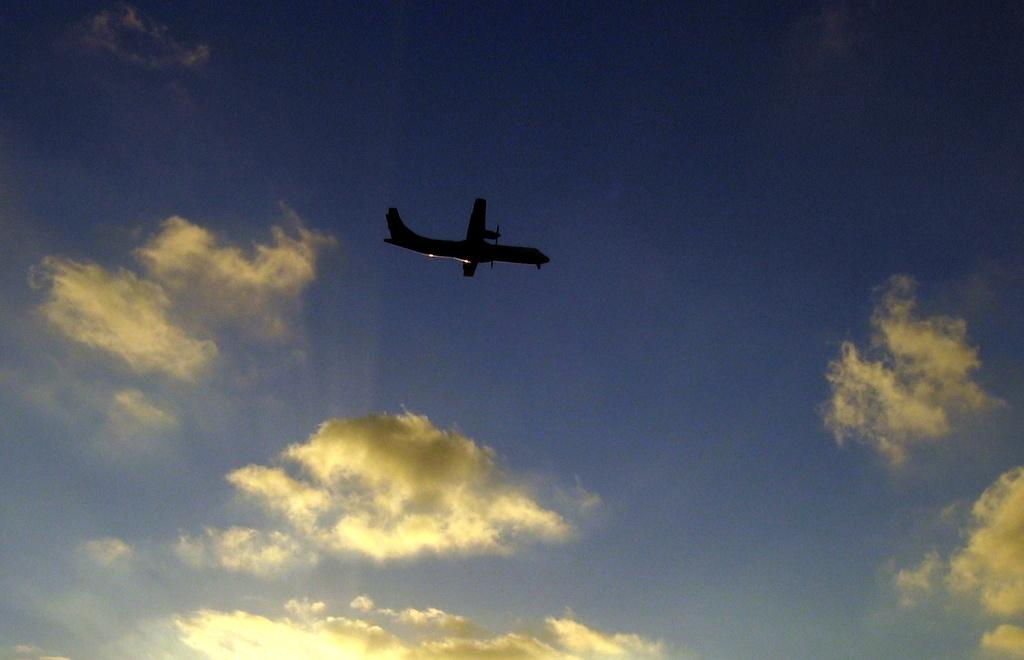What is the main subject of the image? There is a plane in the image. What is the plane doing in the image? The plane is flying in the air. What can be seen in the background of the image? There are clouds visible in the image. Where is the key located in the image? There is no key present in the image. What type of sea creature can be seen swimming in the image? There is no sea or sea creature present in the image; it features a plane flying in the air. 